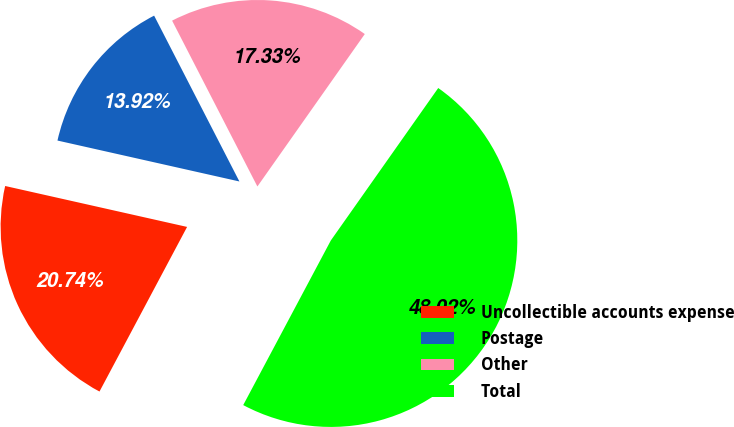<chart> <loc_0><loc_0><loc_500><loc_500><pie_chart><fcel>Uncollectible accounts expense<fcel>Postage<fcel>Other<fcel>Total<nl><fcel>20.74%<fcel>13.92%<fcel>17.33%<fcel>48.02%<nl></chart> 